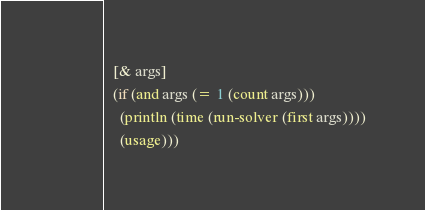Convert code to text. <code><loc_0><loc_0><loc_500><loc_500><_Clojure_>  [& args]
  (if (and args (= 1 (count args)))
    (println (time (run-solver (first args))))
    (usage)))
</code> 